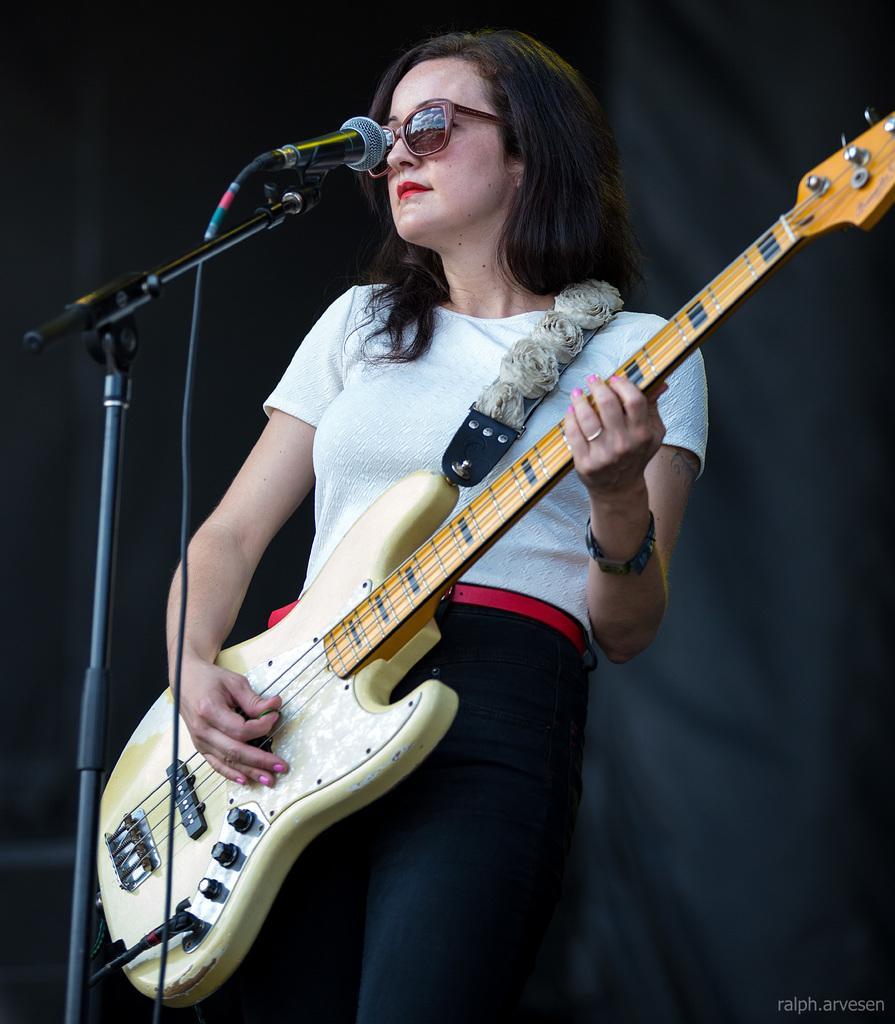In one or two sentences, can you explain what this image depicts? This woman is playing guitar. In-front of this woman there is a mic. Background it is in black color. 